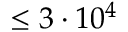<formula> <loc_0><loc_0><loc_500><loc_500>\leq 3 \cdot 1 0 ^ { 4 }</formula> 